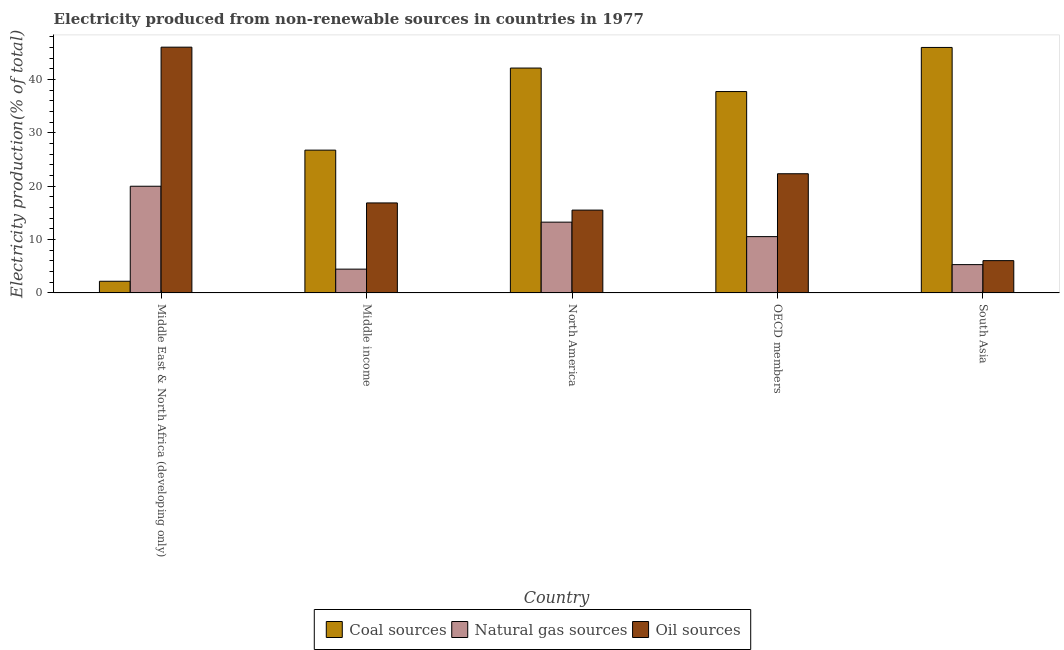Are the number of bars on each tick of the X-axis equal?
Your answer should be compact. Yes. What is the label of the 1st group of bars from the left?
Your response must be concise. Middle East & North Africa (developing only). In how many cases, is the number of bars for a given country not equal to the number of legend labels?
Ensure brevity in your answer.  0. What is the percentage of electricity produced by oil sources in South Asia?
Your response must be concise. 6.06. Across all countries, what is the maximum percentage of electricity produced by oil sources?
Offer a very short reply. 46.09. Across all countries, what is the minimum percentage of electricity produced by oil sources?
Your answer should be very brief. 6.06. In which country was the percentage of electricity produced by natural gas maximum?
Your answer should be compact. Middle East & North Africa (developing only). What is the total percentage of electricity produced by natural gas in the graph?
Offer a very short reply. 53.62. What is the difference between the percentage of electricity produced by oil sources in Middle income and that in South Asia?
Keep it short and to the point. 10.82. What is the difference between the percentage of electricity produced by oil sources in OECD members and the percentage of electricity produced by coal in South Asia?
Provide a succinct answer. -23.69. What is the average percentage of electricity produced by coal per country?
Offer a terse response. 30.99. What is the difference between the percentage of electricity produced by oil sources and percentage of electricity produced by coal in OECD members?
Your answer should be compact. -15.41. In how many countries, is the percentage of electricity produced by natural gas greater than 40 %?
Offer a very short reply. 0. What is the ratio of the percentage of electricity produced by coal in North America to that in OECD members?
Make the answer very short. 1.12. Is the percentage of electricity produced by coal in North America less than that in South Asia?
Your response must be concise. Yes. What is the difference between the highest and the second highest percentage of electricity produced by oil sources?
Make the answer very short. 23.74. What is the difference between the highest and the lowest percentage of electricity produced by natural gas?
Offer a very short reply. 15.54. Is the sum of the percentage of electricity produced by natural gas in North America and OECD members greater than the maximum percentage of electricity produced by oil sources across all countries?
Offer a terse response. No. What does the 3rd bar from the left in Middle income represents?
Provide a short and direct response. Oil sources. What does the 2nd bar from the right in North America represents?
Your answer should be compact. Natural gas sources. How many bars are there?
Provide a short and direct response. 15. Are all the bars in the graph horizontal?
Provide a succinct answer. No. How many countries are there in the graph?
Give a very brief answer. 5. What is the difference between two consecutive major ticks on the Y-axis?
Ensure brevity in your answer.  10. Are the values on the major ticks of Y-axis written in scientific E-notation?
Your answer should be compact. No. Does the graph contain any zero values?
Your response must be concise. No. Where does the legend appear in the graph?
Provide a short and direct response. Bottom center. How are the legend labels stacked?
Make the answer very short. Horizontal. What is the title of the graph?
Provide a succinct answer. Electricity produced from non-renewable sources in countries in 1977. Does "Coal" appear as one of the legend labels in the graph?
Keep it short and to the point. No. What is the Electricity production(% of total) in Coal sources in Middle East & North Africa (developing only)?
Make the answer very short. 2.19. What is the Electricity production(% of total) of Natural gas sources in Middle East & North Africa (developing only)?
Provide a succinct answer. 20.01. What is the Electricity production(% of total) of Oil sources in Middle East & North Africa (developing only)?
Provide a succinct answer. 46.09. What is the Electricity production(% of total) of Coal sources in Middle income?
Offer a very short reply. 26.78. What is the Electricity production(% of total) in Natural gas sources in Middle income?
Give a very brief answer. 4.46. What is the Electricity production(% of total) of Oil sources in Middle income?
Ensure brevity in your answer.  16.88. What is the Electricity production(% of total) of Coal sources in North America?
Your answer should be compact. 42.17. What is the Electricity production(% of total) of Natural gas sources in North America?
Give a very brief answer. 13.28. What is the Electricity production(% of total) of Oil sources in North America?
Keep it short and to the point. 15.54. What is the Electricity production(% of total) in Coal sources in OECD members?
Give a very brief answer. 37.77. What is the Electricity production(% of total) of Natural gas sources in OECD members?
Keep it short and to the point. 10.56. What is the Electricity production(% of total) of Oil sources in OECD members?
Your answer should be very brief. 22.35. What is the Electricity production(% of total) of Coal sources in South Asia?
Your answer should be compact. 46.04. What is the Electricity production(% of total) in Natural gas sources in South Asia?
Provide a short and direct response. 5.31. What is the Electricity production(% of total) of Oil sources in South Asia?
Offer a very short reply. 6.06. Across all countries, what is the maximum Electricity production(% of total) of Coal sources?
Your response must be concise. 46.04. Across all countries, what is the maximum Electricity production(% of total) in Natural gas sources?
Offer a very short reply. 20.01. Across all countries, what is the maximum Electricity production(% of total) of Oil sources?
Offer a terse response. 46.09. Across all countries, what is the minimum Electricity production(% of total) in Coal sources?
Your answer should be compact. 2.19. Across all countries, what is the minimum Electricity production(% of total) of Natural gas sources?
Ensure brevity in your answer.  4.46. Across all countries, what is the minimum Electricity production(% of total) in Oil sources?
Make the answer very short. 6.06. What is the total Electricity production(% of total) of Coal sources in the graph?
Your answer should be very brief. 154.95. What is the total Electricity production(% of total) in Natural gas sources in the graph?
Keep it short and to the point. 53.62. What is the total Electricity production(% of total) of Oil sources in the graph?
Offer a very short reply. 106.92. What is the difference between the Electricity production(% of total) in Coal sources in Middle East & North Africa (developing only) and that in Middle income?
Ensure brevity in your answer.  -24.59. What is the difference between the Electricity production(% of total) in Natural gas sources in Middle East & North Africa (developing only) and that in Middle income?
Your answer should be very brief. 15.54. What is the difference between the Electricity production(% of total) of Oil sources in Middle East & North Africa (developing only) and that in Middle income?
Ensure brevity in your answer.  29.21. What is the difference between the Electricity production(% of total) in Coal sources in Middle East & North Africa (developing only) and that in North America?
Ensure brevity in your answer.  -39.98. What is the difference between the Electricity production(% of total) of Natural gas sources in Middle East & North Africa (developing only) and that in North America?
Keep it short and to the point. 6.73. What is the difference between the Electricity production(% of total) of Oil sources in Middle East & North Africa (developing only) and that in North America?
Your response must be concise. 30.55. What is the difference between the Electricity production(% of total) of Coal sources in Middle East & North Africa (developing only) and that in OECD members?
Offer a very short reply. -35.58. What is the difference between the Electricity production(% of total) of Natural gas sources in Middle East & North Africa (developing only) and that in OECD members?
Provide a short and direct response. 9.45. What is the difference between the Electricity production(% of total) of Oil sources in Middle East & North Africa (developing only) and that in OECD members?
Provide a succinct answer. 23.74. What is the difference between the Electricity production(% of total) of Coal sources in Middle East & North Africa (developing only) and that in South Asia?
Provide a succinct answer. -43.85. What is the difference between the Electricity production(% of total) of Natural gas sources in Middle East & North Africa (developing only) and that in South Asia?
Provide a succinct answer. 14.7. What is the difference between the Electricity production(% of total) of Oil sources in Middle East & North Africa (developing only) and that in South Asia?
Your answer should be very brief. 40.03. What is the difference between the Electricity production(% of total) in Coal sources in Middle income and that in North America?
Provide a succinct answer. -15.39. What is the difference between the Electricity production(% of total) in Natural gas sources in Middle income and that in North America?
Your answer should be very brief. -8.81. What is the difference between the Electricity production(% of total) in Oil sources in Middle income and that in North America?
Your answer should be compact. 1.34. What is the difference between the Electricity production(% of total) of Coal sources in Middle income and that in OECD members?
Your answer should be compact. -10.98. What is the difference between the Electricity production(% of total) in Natural gas sources in Middle income and that in OECD members?
Give a very brief answer. -6.1. What is the difference between the Electricity production(% of total) in Oil sources in Middle income and that in OECD members?
Your response must be concise. -5.47. What is the difference between the Electricity production(% of total) of Coal sources in Middle income and that in South Asia?
Offer a terse response. -19.26. What is the difference between the Electricity production(% of total) of Natural gas sources in Middle income and that in South Asia?
Give a very brief answer. -0.85. What is the difference between the Electricity production(% of total) of Oil sources in Middle income and that in South Asia?
Offer a very short reply. 10.82. What is the difference between the Electricity production(% of total) of Coal sources in North America and that in OECD members?
Ensure brevity in your answer.  4.41. What is the difference between the Electricity production(% of total) of Natural gas sources in North America and that in OECD members?
Ensure brevity in your answer.  2.71. What is the difference between the Electricity production(% of total) in Oil sources in North America and that in OECD members?
Your answer should be compact. -6.82. What is the difference between the Electricity production(% of total) in Coal sources in North America and that in South Asia?
Give a very brief answer. -3.86. What is the difference between the Electricity production(% of total) in Natural gas sources in North America and that in South Asia?
Offer a very short reply. 7.97. What is the difference between the Electricity production(% of total) of Oil sources in North America and that in South Asia?
Offer a very short reply. 9.48. What is the difference between the Electricity production(% of total) in Coal sources in OECD members and that in South Asia?
Make the answer very short. -8.27. What is the difference between the Electricity production(% of total) in Natural gas sources in OECD members and that in South Asia?
Offer a terse response. 5.25. What is the difference between the Electricity production(% of total) in Oil sources in OECD members and that in South Asia?
Keep it short and to the point. 16.3. What is the difference between the Electricity production(% of total) in Coal sources in Middle East & North Africa (developing only) and the Electricity production(% of total) in Natural gas sources in Middle income?
Offer a terse response. -2.27. What is the difference between the Electricity production(% of total) in Coal sources in Middle East & North Africa (developing only) and the Electricity production(% of total) in Oil sources in Middle income?
Ensure brevity in your answer.  -14.69. What is the difference between the Electricity production(% of total) of Natural gas sources in Middle East & North Africa (developing only) and the Electricity production(% of total) of Oil sources in Middle income?
Keep it short and to the point. 3.13. What is the difference between the Electricity production(% of total) of Coal sources in Middle East & North Africa (developing only) and the Electricity production(% of total) of Natural gas sources in North America?
Ensure brevity in your answer.  -11.09. What is the difference between the Electricity production(% of total) of Coal sources in Middle East & North Africa (developing only) and the Electricity production(% of total) of Oil sources in North America?
Your answer should be compact. -13.35. What is the difference between the Electricity production(% of total) of Natural gas sources in Middle East & North Africa (developing only) and the Electricity production(% of total) of Oil sources in North America?
Your answer should be compact. 4.47. What is the difference between the Electricity production(% of total) in Coal sources in Middle East & North Africa (developing only) and the Electricity production(% of total) in Natural gas sources in OECD members?
Your response must be concise. -8.37. What is the difference between the Electricity production(% of total) of Coal sources in Middle East & North Africa (developing only) and the Electricity production(% of total) of Oil sources in OECD members?
Provide a succinct answer. -20.16. What is the difference between the Electricity production(% of total) in Natural gas sources in Middle East & North Africa (developing only) and the Electricity production(% of total) in Oil sources in OECD members?
Keep it short and to the point. -2.34. What is the difference between the Electricity production(% of total) in Coal sources in Middle East & North Africa (developing only) and the Electricity production(% of total) in Natural gas sources in South Asia?
Ensure brevity in your answer.  -3.12. What is the difference between the Electricity production(% of total) of Coal sources in Middle East & North Africa (developing only) and the Electricity production(% of total) of Oil sources in South Asia?
Make the answer very short. -3.87. What is the difference between the Electricity production(% of total) of Natural gas sources in Middle East & North Africa (developing only) and the Electricity production(% of total) of Oil sources in South Asia?
Offer a terse response. 13.95. What is the difference between the Electricity production(% of total) in Coal sources in Middle income and the Electricity production(% of total) in Natural gas sources in North America?
Provide a short and direct response. 13.51. What is the difference between the Electricity production(% of total) of Coal sources in Middle income and the Electricity production(% of total) of Oil sources in North America?
Your answer should be compact. 11.25. What is the difference between the Electricity production(% of total) in Natural gas sources in Middle income and the Electricity production(% of total) in Oil sources in North America?
Ensure brevity in your answer.  -11.07. What is the difference between the Electricity production(% of total) in Coal sources in Middle income and the Electricity production(% of total) in Natural gas sources in OECD members?
Keep it short and to the point. 16.22. What is the difference between the Electricity production(% of total) in Coal sources in Middle income and the Electricity production(% of total) in Oil sources in OECD members?
Your response must be concise. 4.43. What is the difference between the Electricity production(% of total) of Natural gas sources in Middle income and the Electricity production(% of total) of Oil sources in OECD members?
Offer a very short reply. -17.89. What is the difference between the Electricity production(% of total) in Coal sources in Middle income and the Electricity production(% of total) in Natural gas sources in South Asia?
Offer a very short reply. 21.47. What is the difference between the Electricity production(% of total) of Coal sources in Middle income and the Electricity production(% of total) of Oil sources in South Asia?
Keep it short and to the point. 20.72. What is the difference between the Electricity production(% of total) of Natural gas sources in Middle income and the Electricity production(% of total) of Oil sources in South Asia?
Your response must be concise. -1.59. What is the difference between the Electricity production(% of total) in Coal sources in North America and the Electricity production(% of total) in Natural gas sources in OECD members?
Your answer should be very brief. 31.61. What is the difference between the Electricity production(% of total) in Coal sources in North America and the Electricity production(% of total) in Oil sources in OECD members?
Provide a short and direct response. 19.82. What is the difference between the Electricity production(% of total) of Natural gas sources in North America and the Electricity production(% of total) of Oil sources in OECD members?
Ensure brevity in your answer.  -9.08. What is the difference between the Electricity production(% of total) in Coal sources in North America and the Electricity production(% of total) in Natural gas sources in South Asia?
Your answer should be very brief. 36.86. What is the difference between the Electricity production(% of total) of Coal sources in North America and the Electricity production(% of total) of Oil sources in South Asia?
Your answer should be very brief. 36.12. What is the difference between the Electricity production(% of total) of Natural gas sources in North America and the Electricity production(% of total) of Oil sources in South Asia?
Ensure brevity in your answer.  7.22. What is the difference between the Electricity production(% of total) in Coal sources in OECD members and the Electricity production(% of total) in Natural gas sources in South Asia?
Your answer should be very brief. 32.46. What is the difference between the Electricity production(% of total) of Coal sources in OECD members and the Electricity production(% of total) of Oil sources in South Asia?
Provide a succinct answer. 31.71. What is the difference between the Electricity production(% of total) in Natural gas sources in OECD members and the Electricity production(% of total) in Oil sources in South Asia?
Provide a short and direct response. 4.5. What is the average Electricity production(% of total) of Coal sources per country?
Offer a terse response. 30.99. What is the average Electricity production(% of total) of Natural gas sources per country?
Make the answer very short. 10.72. What is the average Electricity production(% of total) in Oil sources per country?
Your answer should be compact. 21.38. What is the difference between the Electricity production(% of total) in Coal sources and Electricity production(% of total) in Natural gas sources in Middle East & North Africa (developing only)?
Offer a terse response. -17.82. What is the difference between the Electricity production(% of total) of Coal sources and Electricity production(% of total) of Oil sources in Middle East & North Africa (developing only)?
Your response must be concise. -43.9. What is the difference between the Electricity production(% of total) of Natural gas sources and Electricity production(% of total) of Oil sources in Middle East & North Africa (developing only)?
Your answer should be compact. -26.08. What is the difference between the Electricity production(% of total) in Coal sources and Electricity production(% of total) in Natural gas sources in Middle income?
Offer a terse response. 22.32. What is the difference between the Electricity production(% of total) of Coal sources and Electricity production(% of total) of Oil sources in Middle income?
Your answer should be very brief. 9.9. What is the difference between the Electricity production(% of total) in Natural gas sources and Electricity production(% of total) in Oil sources in Middle income?
Keep it short and to the point. -12.41. What is the difference between the Electricity production(% of total) in Coal sources and Electricity production(% of total) in Natural gas sources in North America?
Your response must be concise. 28.9. What is the difference between the Electricity production(% of total) in Coal sources and Electricity production(% of total) in Oil sources in North America?
Keep it short and to the point. 26.64. What is the difference between the Electricity production(% of total) in Natural gas sources and Electricity production(% of total) in Oil sources in North America?
Ensure brevity in your answer.  -2.26. What is the difference between the Electricity production(% of total) in Coal sources and Electricity production(% of total) in Natural gas sources in OECD members?
Offer a terse response. 27.2. What is the difference between the Electricity production(% of total) of Coal sources and Electricity production(% of total) of Oil sources in OECD members?
Ensure brevity in your answer.  15.41. What is the difference between the Electricity production(% of total) in Natural gas sources and Electricity production(% of total) in Oil sources in OECD members?
Offer a terse response. -11.79. What is the difference between the Electricity production(% of total) in Coal sources and Electricity production(% of total) in Natural gas sources in South Asia?
Your answer should be very brief. 40.73. What is the difference between the Electricity production(% of total) in Coal sources and Electricity production(% of total) in Oil sources in South Asia?
Provide a short and direct response. 39.98. What is the difference between the Electricity production(% of total) in Natural gas sources and Electricity production(% of total) in Oil sources in South Asia?
Keep it short and to the point. -0.75. What is the ratio of the Electricity production(% of total) of Coal sources in Middle East & North Africa (developing only) to that in Middle income?
Give a very brief answer. 0.08. What is the ratio of the Electricity production(% of total) in Natural gas sources in Middle East & North Africa (developing only) to that in Middle income?
Keep it short and to the point. 4.48. What is the ratio of the Electricity production(% of total) in Oil sources in Middle East & North Africa (developing only) to that in Middle income?
Give a very brief answer. 2.73. What is the ratio of the Electricity production(% of total) of Coal sources in Middle East & North Africa (developing only) to that in North America?
Provide a succinct answer. 0.05. What is the ratio of the Electricity production(% of total) in Natural gas sources in Middle East & North Africa (developing only) to that in North America?
Keep it short and to the point. 1.51. What is the ratio of the Electricity production(% of total) of Oil sources in Middle East & North Africa (developing only) to that in North America?
Your response must be concise. 2.97. What is the ratio of the Electricity production(% of total) in Coal sources in Middle East & North Africa (developing only) to that in OECD members?
Your answer should be compact. 0.06. What is the ratio of the Electricity production(% of total) of Natural gas sources in Middle East & North Africa (developing only) to that in OECD members?
Offer a terse response. 1.89. What is the ratio of the Electricity production(% of total) in Oil sources in Middle East & North Africa (developing only) to that in OECD members?
Your answer should be compact. 2.06. What is the ratio of the Electricity production(% of total) of Coal sources in Middle East & North Africa (developing only) to that in South Asia?
Offer a very short reply. 0.05. What is the ratio of the Electricity production(% of total) of Natural gas sources in Middle East & North Africa (developing only) to that in South Asia?
Offer a terse response. 3.77. What is the ratio of the Electricity production(% of total) in Oil sources in Middle East & North Africa (developing only) to that in South Asia?
Offer a terse response. 7.61. What is the ratio of the Electricity production(% of total) of Coal sources in Middle income to that in North America?
Keep it short and to the point. 0.64. What is the ratio of the Electricity production(% of total) of Natural gas sources in Middle income to that in North America?
Your answer should be compact. 0.34. What is the ratio of the Electricity production(% of total) of Oil sources in Middle income to that in North America?
Offer a terse response. 1.09. What is the ratio of the Electricity production(% of total) of Coal sources in Middle income to that in OECD members?
Your answer should be very brief. 0.71. What is the ratio of the Electricity production(% of total) of Natural gas sources in Middle income to that in OECD members?
Make the answer very short. 0.42. What is the ratio of the Electricity production(% of total) in Oil sources in Middle income to that in OECD members?
Provide a short and direct response. 0.76. What is the ratio of the Electricity production(% of total) in Coal sources in Middle income to that in South Asia?
Keep it short and to the point. 0.58. What is the ratio of the Electricity production(% of total) in Natural gas sources in Middle income to that in South Asia?
Give a very brief answer. 0.84. What is the ratio of the Electricity production(% of total) of Oil sources in Middle income to that in South Asia?
Your answer should be compact. 2.79. What is the ratio of the Electricity production(% of total) in Coal sources in North America to that in OECD members?
Your response must be concise. 1.12. What is the ratio of the Electricity production(% of total) of Natural gas sources in North America to that in OECD members?
Offer a terse response. 1.26. What is the ratio of the Electricity production(% of total) in Oil sources in North America to that in OECD members?
Your response must be concise. 0.69. What is the ratio of the Electricity production(% of total) in Coal sources in North America to that in South Asia?
Make the answer very short. 0.92. What is the ratio of the Electricity production(% of total) in Natural gas sources in North America to that in South Asia?
Your answer should be compact. 2.5. What is the ratio of the Electricity production(% of total) in Oil sources in North America to that in South Asia?
Provide a short and direct response. 2.56. What is the ratio of the Electricity production(% of total) in Coal sources in OECD members to that in South Asia?
Provide a short and direct response. 0.82. What is the ratio of the Electricity production(% of total) of Natural gas sources in OECD members to that in South Asia?
Give a very brief answer. 1.99. What is the ratio of the Electricity production(% of total) in Oil sources in OECD members to that in South Asia?
Give a very brief answer. 3.69. What is the difference between the highest and the second highest Electricity production(% of total) in Coal sources?
Provide a succinct answer. 3.86. What is the difference between the highest and the second highest Electricity production(% of total) in Natural gas sources?
Your answer should be very brief. 6.73. What is the difference between the highest and the second highest Electricity production(% of total) of Oil sources?
Your response must be concise. 23.74. What is the difference between the highest and the lowest Electricity production(% of total) in Coal sources?
Your answer should be very brief. 43.85. What is the difference between the highest and the lowest Electricity production(% of total) in Natural gas sources?
Offer a terse response. 15.54. What is the difference between the highest and the lowest Electricity production(% of total) in Oil sources?
Make the answer very short. 40.03. 